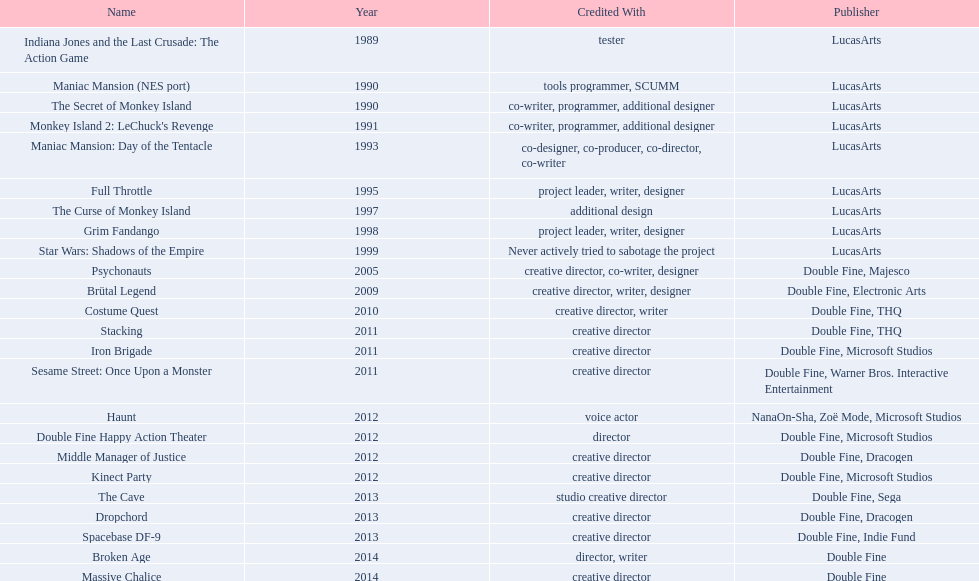What game designation is associated with tim schafer's involvement? Indiana Jones and the Last Crusade: The Action Game, Maniac Mansion (NES port), The Secret of Monkey Island, Monkey Island 2: LeChuck's Revenge, Maniac Mansion: Day of the Tentacle, Full Throttle, The Curse of Monkey Island, Grim Fandango, Star Wars: Shadows of the Empire, Psychonauts, Brütal Legend, Costume Quest, Stacking, Iron Brigade, Sesame Street: Once Upon a Monster, Haunt, Double Fine Happy Action Theater, Middle Manager of Justice, Kinect Party, The Cave, Dropchord, Spacebase DF-9, Broken Age, Massive Chalice. Which game has attribution linked to just the creative head? Creative director, creative director, creative director, creative director, creative director, creative director, creative director, creative director. Which games feature both the above and warner bros. interactive entertainment as the publishing entity? Sesame Street: Once Upon a Monster. 